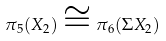<formula> <loc_0><loc_0><loc_500><loc_500>\pi _ { 5 } ( X _ { 2 } ) \cong \pi _ { 6 } ( \Sigma X _ { 2 } )</formula> 